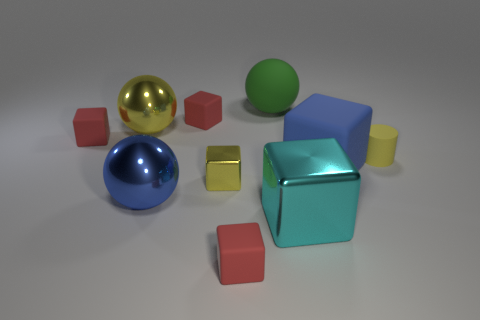Is the number of small yellow matte cylinders to the left of the large green matte ball greater than the number of large metal things?
Ensure brevity in your answer.  No. The shiny thing that is behind the metal block left of the green ball is what color?
Your answer should be compact. Yellow. What number of things are tiny red rubber things in front of the small yellow matte object or small red matte objects that are right of the small metallic block?
Keep it short and to the point. 1. What is the color of the small metal cube?
Make the answer very short. Yellow. How many big cyan objects have the same material as the large blue block?
Provide a short and direct response. 0. Are there more yellow metallic spheres than tiny red matte blocks?
Ensure brevity in your answer.  No. How many blue things are right of the small matte thing behind the big yellow shiny sphere?
Give a very brief answer. 1. How many objects are either matte things that are in front of the yellow matte object or large cubes?
Offer a very short reply. 3. Are there any yellow shiny objects that have the same shape as the cyan object?
Keep it short and to the point. Yes. There is a blue thing that is on the right side of the large metallic ball that is in front of the small yellow rubber cylinder; what shape is it?
Provide a short and direct response. Cube. 